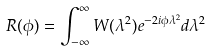Convert formula to latex. <formula><loc_0><loc_0><loc_500><loc_500>R ( \phi ) = \int ^ { \infty } _ { - \infty } W ( \lambda ^ { 2 } ) e ^ { - 2 i \phi \lambda ^ { 2 } } d \lambda ^ { 2 }</formula> 